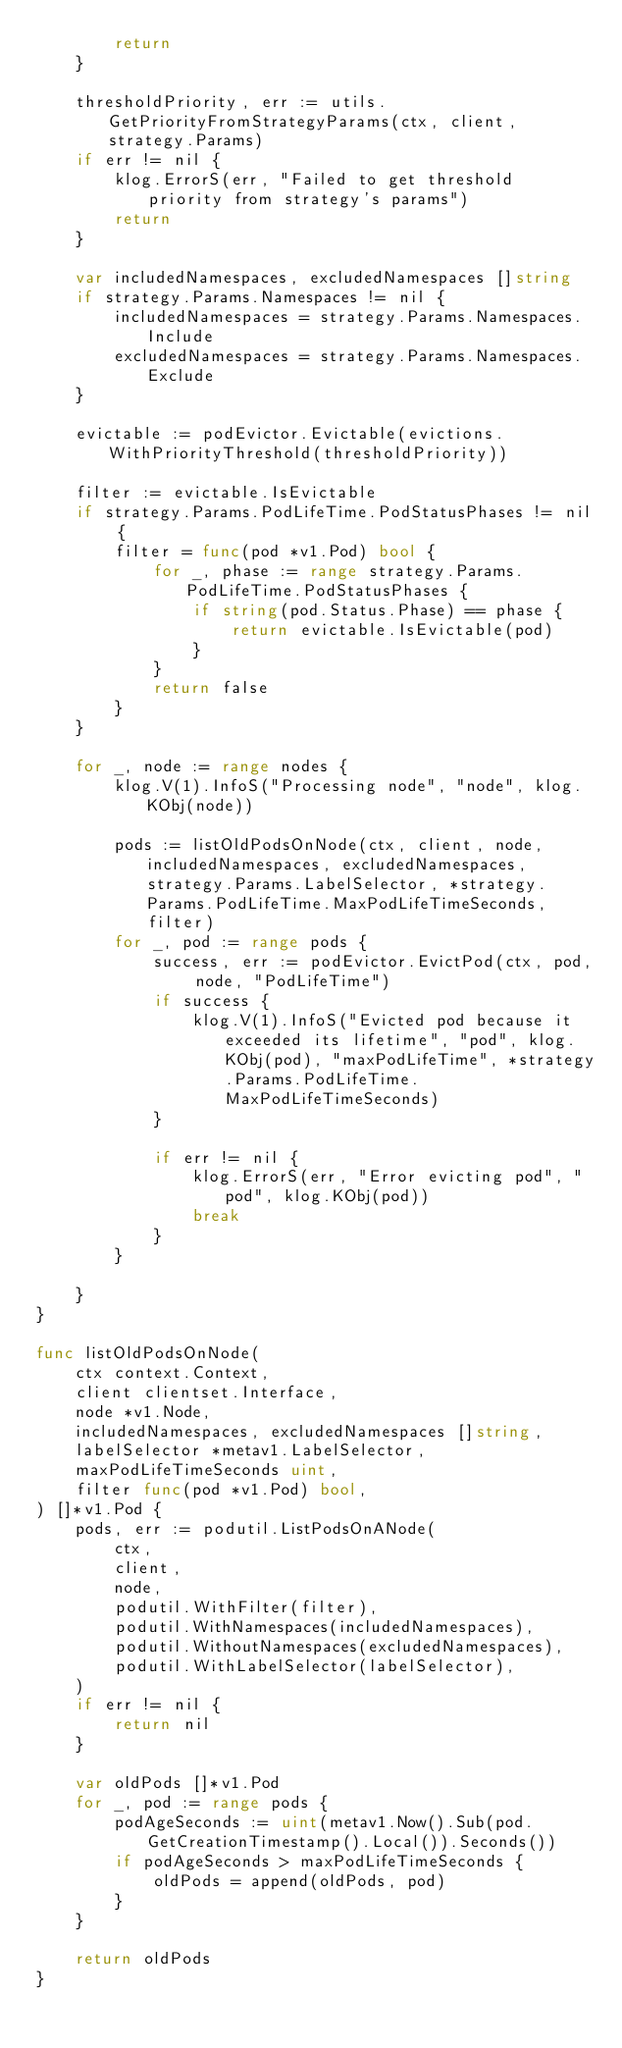<code> <loc_0><loc_0><loc_500><loc_500><_Go_>		return
	}

	thresholdPriority, err := utils.GetPriorityFromStrategyParams(ctx, client, strategy.Params)
	if err != nil {
		klog.ErrorS(err, "Failed to get threshold priority from strategy's params")
		return
	}

	var includedNamespaces, excludedNamespaces []string
	if strategy.Params.Namespaces != nil {
		includedNamespaces = strategy.Params.Namespaces.Include
		excludedNamespaces = strategy.Params.Namespaces.Exclude
	}

	evictable := podEvictor.Evictable(evictions.WithPriorityThreshold(thresholdPriority))

	filter := evictable.IsEvictable
	if strategy.Params.PodLifeTime.PodStatusPhases != nil {
		filter = func(pod *v1.Pod) bool {
			for _, phase := range strategy.Params.PodLifeTime.PodStatusPhases {
				if string(pod.Status.Phase) == phase {
					return evictable.IsEvictable(pod)
				}
			}
			return false
		}
	}

	for _, node := range nodes {
		klog.V(1).InfoS("Processing node", "node", klog.KObj(node))

		pods := listOldPodsOnNode(ctx, client, node, includedNamespaces, excludedNamespaces, strategy.Params.LabelSelector, *strategy.Params.PodLifeTime.MaxPodLifeTimeSeconds, filter)
		for _, pod := range pods {
			success, err := podEvictor.EvictPod(ctx, pod, node, "PodLifeTime")
			if success {
				klog.V(1).InfoS("Evicted pod because it exceeded its lifetime", "pod", klog.KObj(pod), "maxPodLifeTime", *strategy.Params.PodLifeTime.MaxPodLifeTimeSeconds)
			}

			if err != nil {
				klog.ErrorS(err, "Error evicting pod", "pod", klog.KObj(pod))
				break
			}
		}

	}
}

func listOldPodsOnNode(
	ctx context.Context,
	client clientset.Interface,
	node *v1.Node,
	includedNamespaces, excludedNamespaces []string,
	labelSelector *metav1.LabelSelector,
	maxPodLifeTimeSeconds uint,
	filter func(pod *v1.Pod) bool,
) []*v1.Pod {
	pods, err := podutil.ListPodsOnANode(
		ctx,
		client,
		node,
		podutil.WithFilter(filter),
		podutil.WithNamespaces(includedNamespaces),
		podutil.WithoutNamespaces(excludedNamespaces),
		podutil.WithLabelSelector(labelSelector),
	)
	if err != nil {
		return nil
	}

	var oldPods []*v1.Pod
	for _, pod := range pods {
		podAgeSeconds := uint(metav1.Now().Sub(pod.GetCreationTimestamp().Local()).Seconds())
		if podAgeSeconds > maxPodLifeTimeSeconds {
			oldPods = append(oldPods, pod)
		}
	}

	return oldPods
}
</code> 